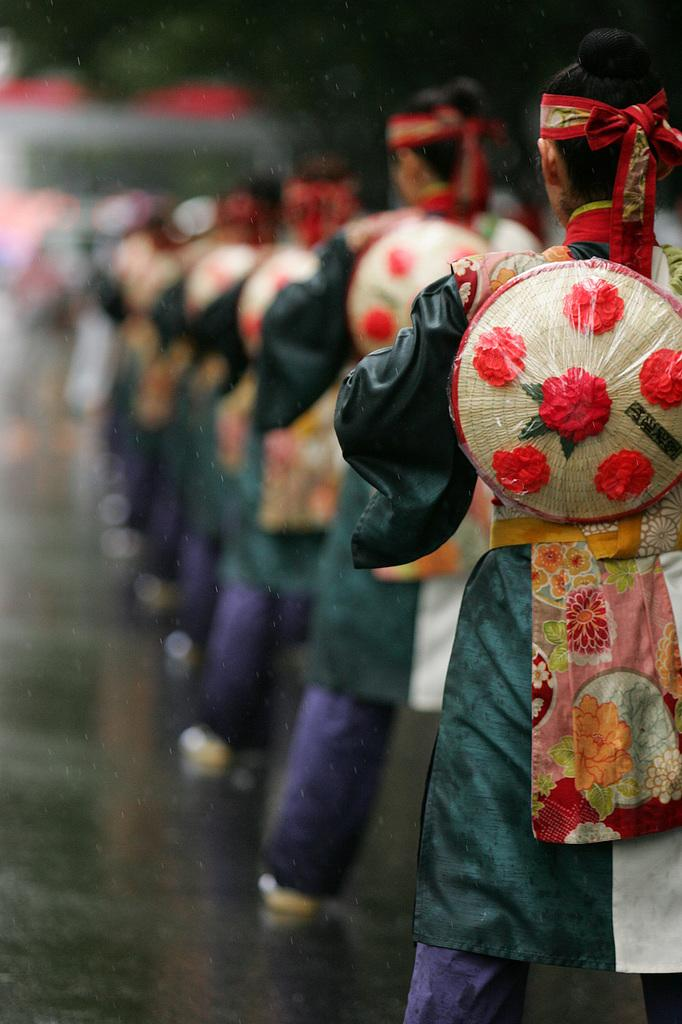What can be seen in the image? There are people standing in the image. What are the people wearing? The people are wearing costumes. Can you describe the background of the image? The backdrop is blurred. What type of summer activity is being performed in the image? The image does not depict a summer activity, nor does it show any specific activity being performed. 